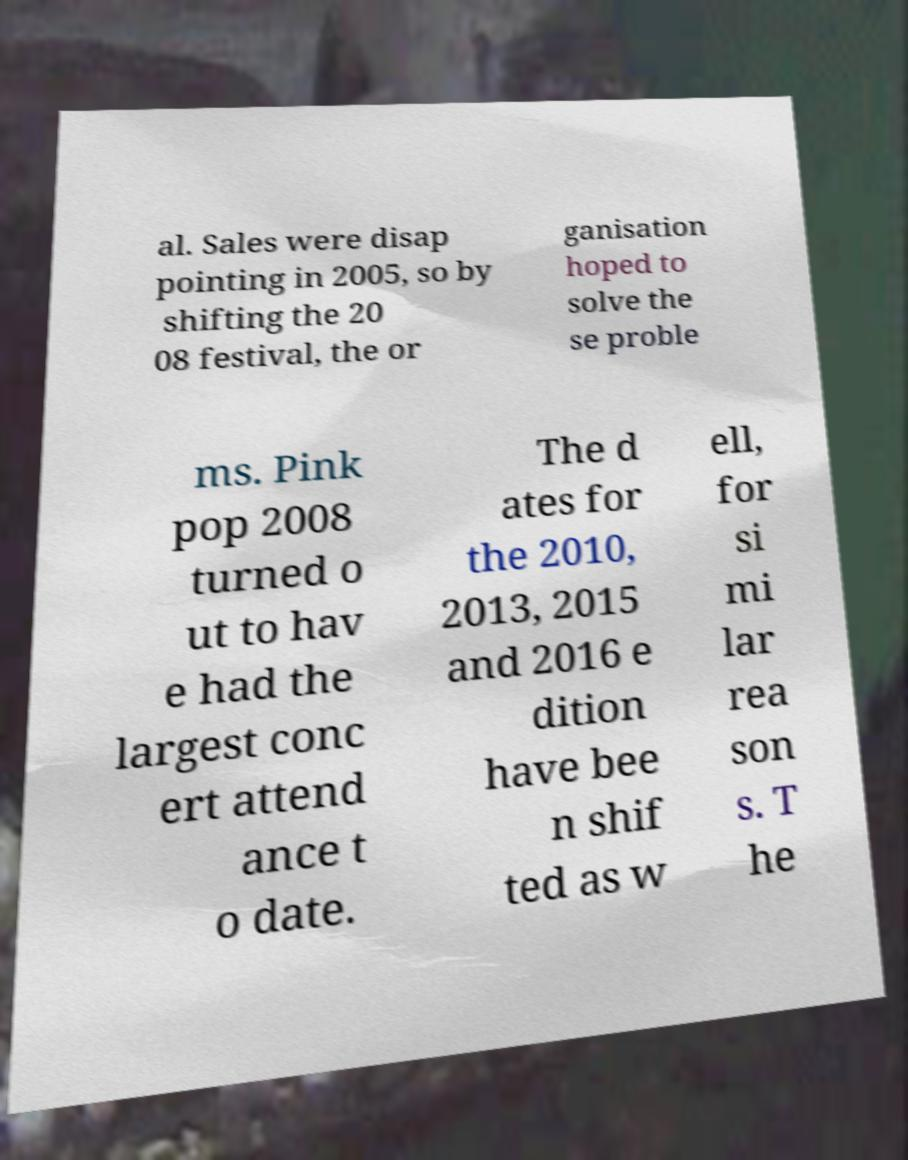For documentation purposes, I need the text within this image transcribed. Could you provide that? al. Sales were disap pointing in 2005, so by shifting the 20 08 festival, the or ganisation hoped to solve the se proble ms. Pink pop 2008 turned o ut to hav e had the largest conc ert attend ance t o date. The d ates for the 2010, 2013, 2015 and 2016 e dition have bee n shif ted as w ell, for si mi lar rea son s. T he 